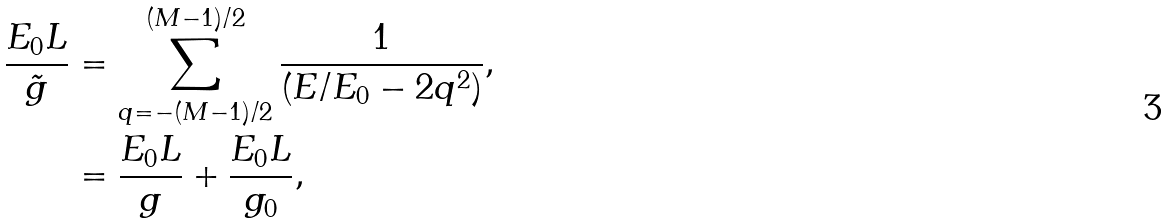<formula> <loc_0><loc_0><loc_500><loc_500>\frac { E _ { 0 } L } { \tilde { g } } & = \sum _ { q = - ( M - 1 ) / 2 } ^ { ( M - 1 ) / 2 } \frac { 1 } { ( E / E _ { 0 } - 2 q ^ { 2 } ) } , \\ & = \frac { E _ { 0 } L } { g } + \frac { E _ { 0 } L } { g _ { 0 } } ,</formula> 